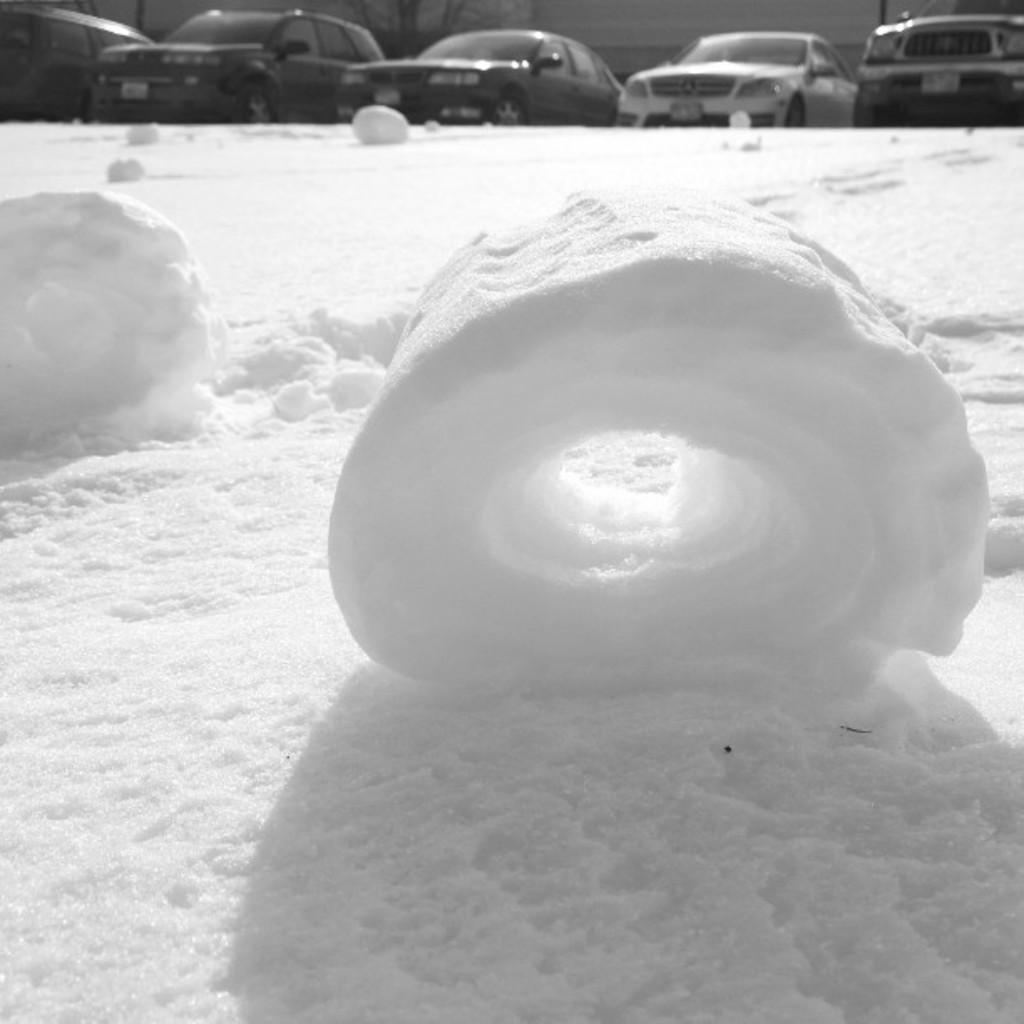What is the primary feature of the image? There is snow in the image. Can you describe the background of the image? There are cars in the background of the image. What type of juice is being squeezed from the potato in the image? There is no juice or potato present in the image; it features snow and cars in the background. 